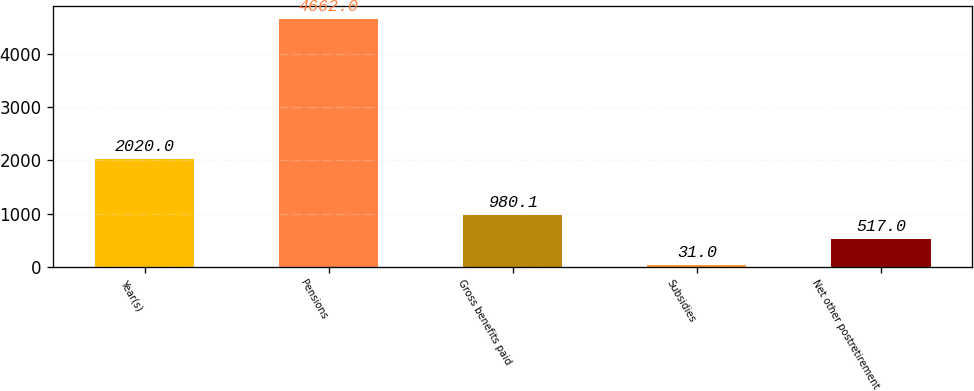Convert chart to OTSL. <chart><loc_0><loc_0><loc_500><loc_500><bar_chart><fcel>Year(s)<fcel>Pensions<fcel>Gross benefits paid<fcel>Subsidies<fcel>Net other postretirement<nl><fcel>2020<fcel>4662<fcel>980.1<fcel>31<fcel>517<nl></chart> 